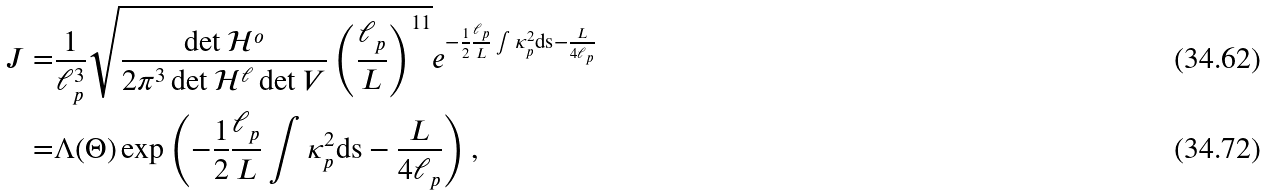Convert formula to latex. <formula><loc_0><loc_0><loc_500><loc_500>J = & \frac { 1 } { \ell _ { p } ^ { 3 } } \sqrt { \frac { \det \mathcal { H } ^ { o } } { 2 \pi ^ { 3 } \det \mathcal { H } ^ { \ell } \det V } \left ( \frac { \ell _ { p } } { L } \right ) ^ { 1 1 } } e ^ { - \frac { 1 } { 2 } \frac { \ell _ { p } } { L } \int \kappa _ { p } ^ { 2 } \text {ds} - \frac { L } { 4 \ell _ { p } } } \\ = & \Lambda ( \Theta ) \exp \left ( - \frac { 1 } { 2 } \frac { \ell _ { p } } { L } \int \kappa _ { p } ^ { 2 } \text {ds} - \frac { L } { 4 \ell _ { p } } \right ) ,</formula> 